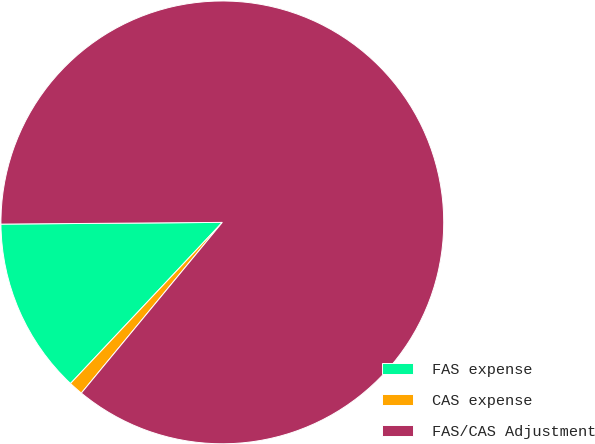Convert chart to OTSL. <chart><loc_0><loc_0><loc_500><loc_500><pie_chart><fcel>FAS expense<fcel>CAS expense<fcel>FAS/CAS Adjustment<nl><fcel>12.85%<fcel>1.04%<fcel>86.11%<nl></chart> 